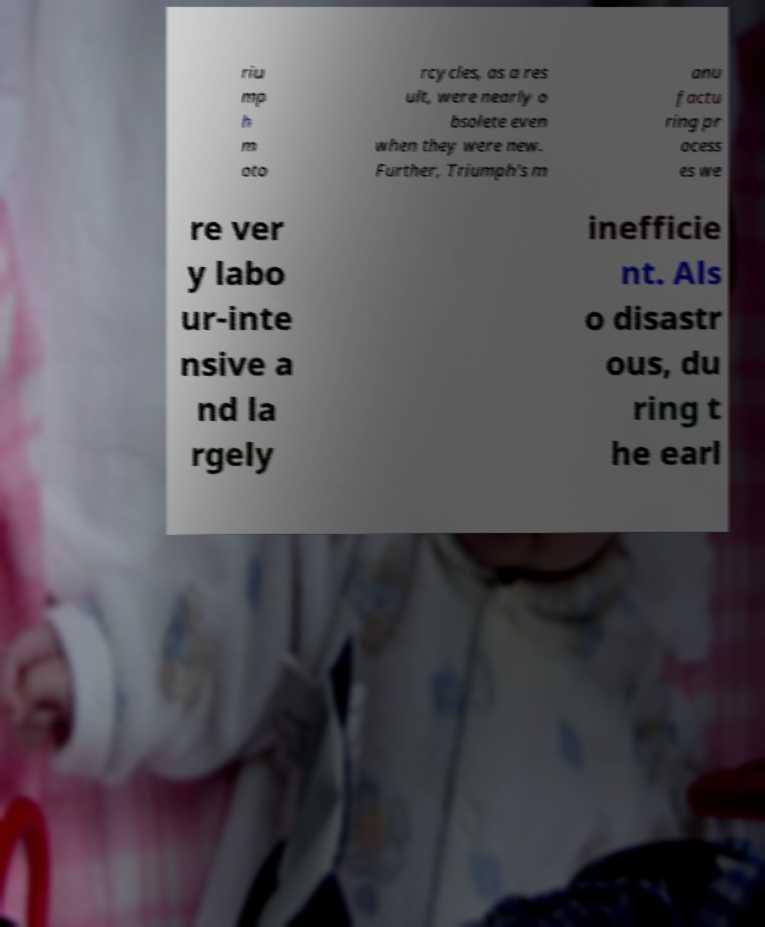I need the written content from this picture converted into text. Can you do that? riu mp h m oto rcycles, as a res ult, were nearly o bsolete even when they were new. Further, Triumph's m anu factu ring pr ocess es we re ver y labo ur-inte nsive a nd la rgely inefficie nt. Als o disastr ous, du ring t he earl 